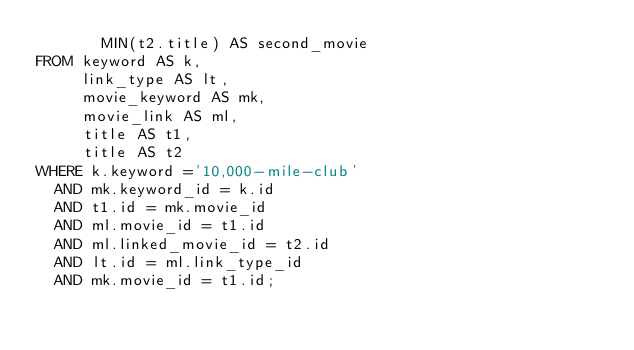Convert code to text. <code><loc_0><loc_0><loc_500><loc_500><_SQL_>       MIN(t2.title) AS second_movie
FROM keyword AS k,
     link_type AS lt,
     movie_keyword AS mk,
     movie_link AS ml,
     title AS t1,
     title AS t2
WHERE k.keyword ='10,000-mile-club'
  AND mk.keyword_id = k.id
  AND t1.id = mk.movie_id
  AND ml.movie_id = t1.id
  AND ml.linked_movie_id = t2.id
  AND lt.id = ml.link_type_id
  AND mk.movie_id = t1.id;

</code> 